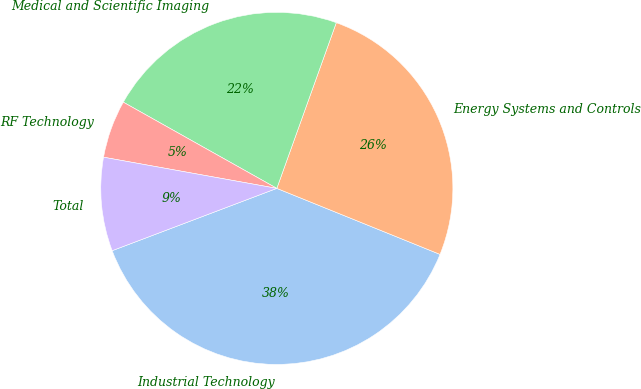Convert chart. <chart><loc_0><loc_0><loc_500><loc_500><pie_chart><fcel>Industrial Technology<fcel>Energy Systems and Controls<fcel>Medical and Scientific Imaging<fcel>RF Technology<fcel>Total<nl><fcel>38.12%<fcel>25.63%<fcel>22.34%<fcel>5.31%<fcel>8.59%<nl></chart> 